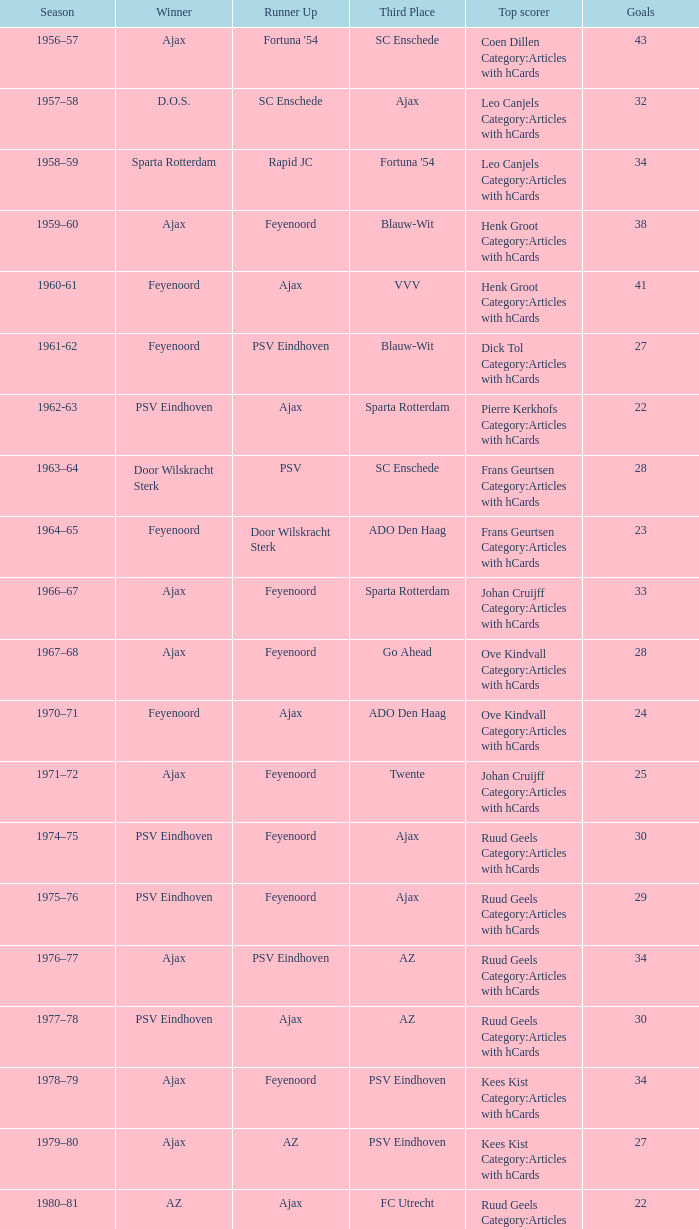In what seasons did twente rank third and ajax become the champion? 1971–72, 1989-90. 